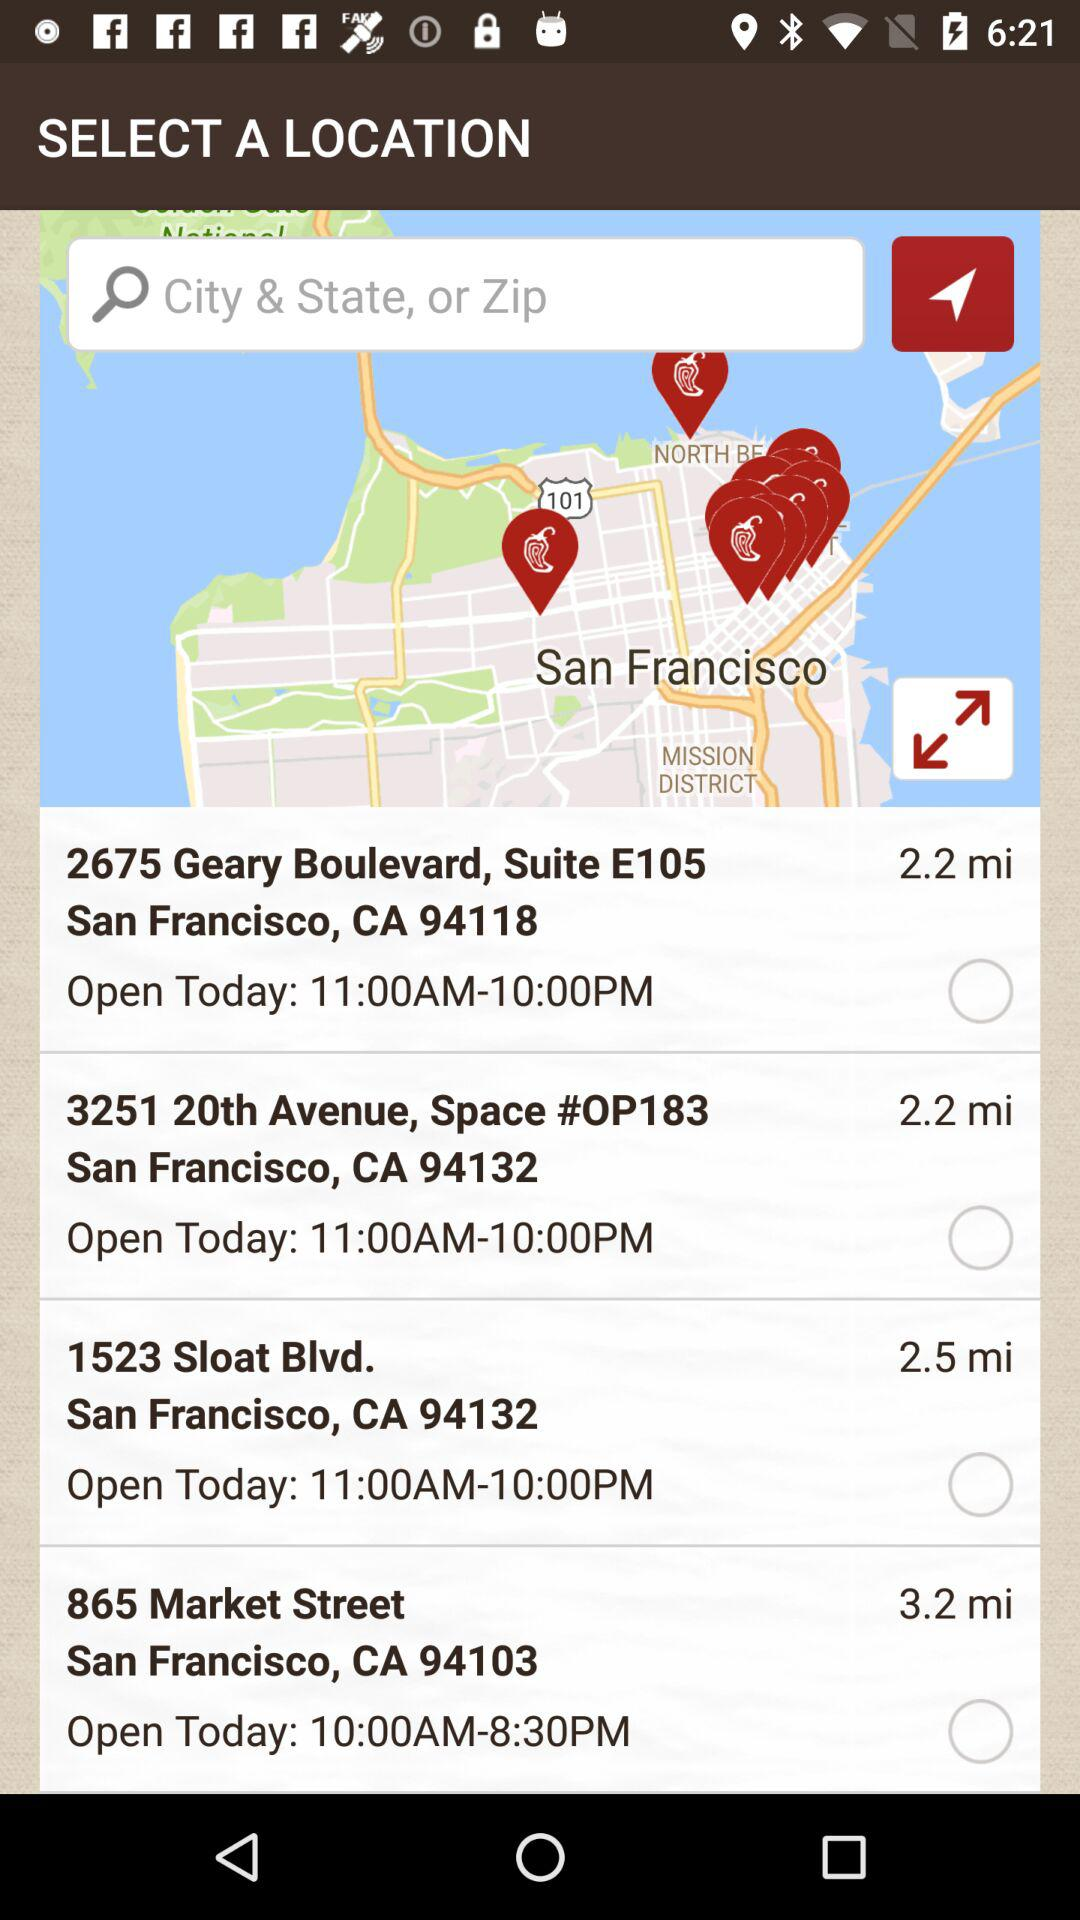How many locations are open today?
Answer the question using a single word or phrase. 4 